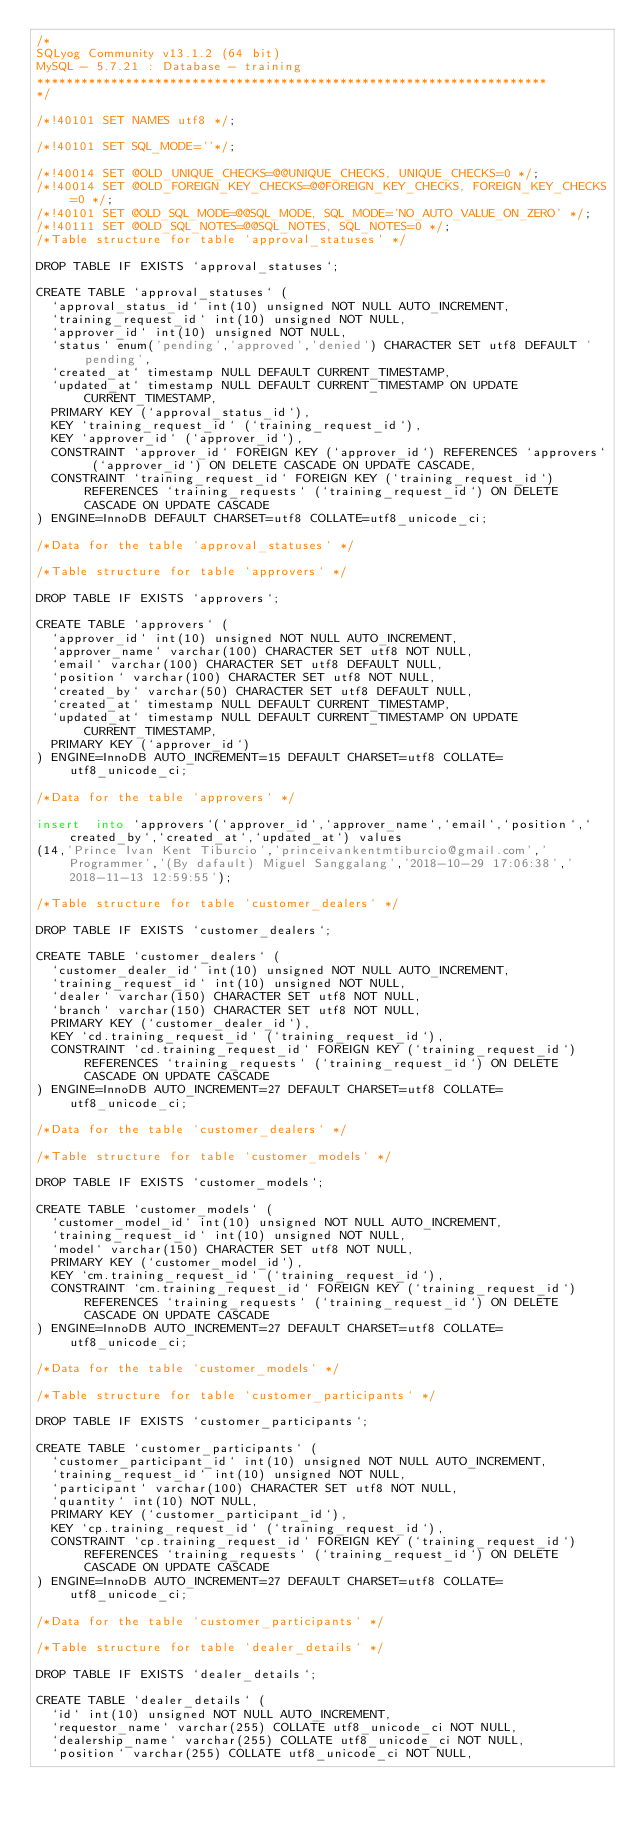<code> <loc_0><loc_0><loc_500><loc_500><_SQL_>/*
SQLyog Community v13.1.2 (64 bit)
MySQL - 5.7.21 : Database - training
*********************************************************************
*/

/*!40101 SET NAMES utf8 */;

/*!40101 SET SQL_MODE=''*/;

/*!40014 SET @OLD_UNIQUE_CHECKS=@@UNIQUE_CHECKS, UNIQUE_CHECKS=0 */;
/*!40014 SET @OLD_FOREIGN_KEY_CHECKS=@@FOREIGN_KEY_CHECKS, FOREIGN_KEY_CHECKS=0 */;
/*!40101 SET @OLD_SQL_MODE=@@SQL_MODE, SQL_MODE='NO_AUTO_VALUE_ON_ZERO' */;
/*!40111 SET @OLD_SQL_NOTES=@@SQL_NOTES, SQL_NOTES=0 */;
/*Table structure for table `approval_statuses` */

DROP TABLE IF EXISTS `approval_statuses`;

CREATE TABLE `approval_statuses` (
  `approval_status_id` int(10) unsigned NOT NULL AUTO_INCREMENT,
  `training_request_id` int(10) unsigned NOT NULL,
  `approver_id` int(10) unsigned NOT NULL,
  `status` enum('pending','approved','denied') CHARACTER SET utf8 DEFAULT 'pending',
  `created_at` timestamp NULL DEFAULT CURRENT_TIMESTAMP,
  `updated_at` timestamp NULL DEFAULT CURRENT_TIMESTAMP ON UPDATE CURRENT_TIMESTAMP,
  PRIMARY KEY (`approval_status_id`),
  KEY `training_request_id` (`training_request_id`),
  KEY `approver_id` (`approver_id`),
  CONSTRAINT `approver_id` FOREIGN KEY (`approver_id`) REFERENCES `approvers` (`approver_id`) ON DELETE CASCADE ON UPDATE CASCADE,
  CONSTRAINT `training_request_id` FOREIGN KEY (`training_request_id`) REFERENCES `training_requests` (`training_request_id`) ON DELETE CASCADE ON UPDATE CASCADE
) ENGINE=InnoDB DEFAULT CHARSET=utf8 COLLATE=utf8_unicode_ci;

/*Data for the table `approval_statuses` */

/*Table structure for table `approvers` */

DROP TABLE IF EXISTS `approvers`;

CREATE TABLE `approvers` (
  `approver_id` int(10) unsigned NOT NULL AUTO_INCREMENT,
  `approver_name` varchar(100) CHARACTER SET utf8 NOT NULL,
  `email` varchar(100) CHARACTER SET utf8 DEFAULT NULL,
  `position` varchar(100) CHARACTER SET utf8 NOT NULL,
  `created_by` varchar(50) CHARACTER SET utf8 DEFAULT NULL,
  `created_at` timestamp NULL DEFAULT CURRENT_TIMESTAMP,
  `updated_at` timestamp NULL DEFAULT CURRENT_TIMESTAMP ON UPDATE CURRENT_TIMESTAMP,
  PRIMARY KEY (`approver_id`)
) ENGINE=InnoDB AUTO_INCREMENT=15 DEFAULT CHARSET=utf8 COLLATE=utf8_unicode_ci;

/*Data for the table `approvers` */

insert  into `approvers`(`approver_id`,`approver_name`,`email`,`position`,`created_by`,`created_at`,`updated_at`) values 
(14,'Prince Ivan Kent Tiburcio','princeivankentmtiburcio@gmail.com','Programmer','(By dafault) Miguel Sanggalang','2018-10-29 17:06:38','2018-11-13 12:59:55');

/*Table structure for table `customer_dealers` */

DROP TABLE IF EXISTS `customer_dealers`;

CREATE TABLE `customer_dealers` (
  `customer_dealer_id` int(10) unsigned NOT NULL AUTO_INCREMENT,
  `training_request_id` int(10) unsigned NOT NULL,
  `dealer` varchar(150) CHARACTER SET utf8 NOT NULL,
  `branch` varchar(150) CHARACTER SET utf8 NOT NULL,
  PRIMARY KEY (`customer_dealer_id`),
  KEY `cd.training_request_id` (`training_request_id`),
  CONSTRAINT `cd.training_request_id` FOREIGN KEY (`training_request_id`) REFERENCES `training_requests` (`training_request_id`) ON DELETE CASCADE ON UPDATE CASCADE
) ENGINE=InnoDB AUTO_INCREMENT=27 DEFAULT CHARSET=utf8 COLLATE=utf8_unicode_ci;

/*Data for the table `customer_dealers` */

/*Table structure for table `customer_models` */

DROP TABLE IF EXISTS `customer_models`;

CREATE TABLE `customer_models` (
  `customer_model_id` int(10) unsigned NOT NULL AUTO_INCREMENT,
  `training_request_id` int(10) unsigned NOT NULL,
  `model` varchar(150) CHARACTER SET utf8 NOT NULL,
  PRIMARY KEY (`customer_model_id`),
  KEY `cm.training_request_id` (`training_request_id`),
  CONSTRAINT `cm.training_request_id` FOREIGN KEY (`training_request_id`) REFERENCES `training_requests` (`training_request_id`) ON DELETE CASCADE ON UPDATE CASCADE
) ENGINE=InnoDB AUTO_INCREMENT=27 DEFAULT CHARSET=utf8 COLLATE=utf8_unicode_ci;

/*Data for the table `customer_models` */

/*Table structure for table `customer_participants` */

DROP TABLE IF EXISTS `customer_participants`;

CREATE TABLE `customer_participants` (
  `customer_participant_id` int(10) unsigned NOT NULL AUTO_INCREMENT,
  `training_request_id` int(10) unsigned NOT NULL,
  `participant` varchar(100) CHARACTER SET utf8 NOT NULL,
  `quantity` int(10) NOT NULL,
  PRIMARY KEY (`customer_participant_id`),
  KEY `cp.training_request_id` (`training_request_id`),
  CONSTRAINT `cp.training_request_id` FOREIGN KEY (`training_request_id`) REFERENCES `training_requests` (`training_request_id`) ON DELETE CASCADE ON UPDATE CASCADE
) ENGINE=InnoDB AUTO_INCREMENT=27 DEFAULT CHARSET=utf8 COLLATE=utf8_unicode_ci;

/*Data for the table `customer_participants` */

/*Table structure for table `dealer_details` */

DROP TABLE IF EXISTS `dealer_details`;

CREATE TABLE `dealer_details` (
  `id` int(10) unsigned NOT NULL AUTO_INCREMENT,
  `requestor_name` varchar(255) COLLATE utf8_unicode_ci NOT NULL,
  `dealership_name` varchar(255) COLLATE utf8_unicode_ci NOT NULL,
  `position` varchar(255) COLLATE utf8_unicode_ci NOT NULL,</code> 